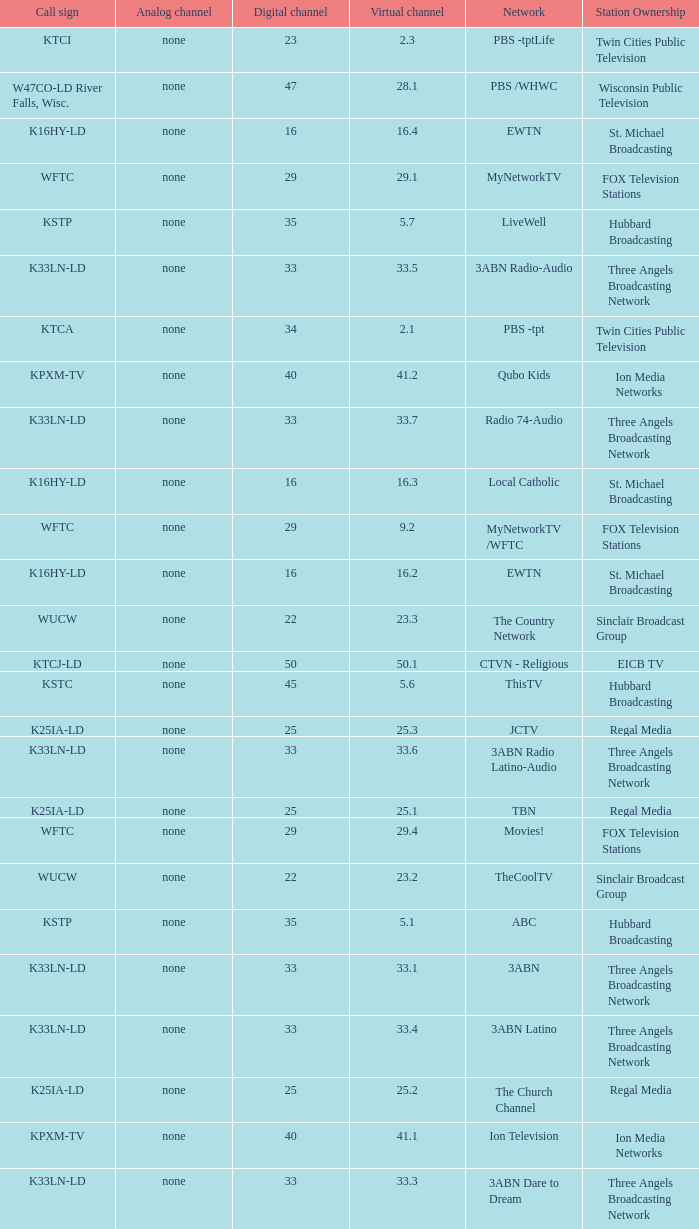Station Ownership of eicb tv, and a Call sign of ktcj-ld is what virtual network? 50.1. 